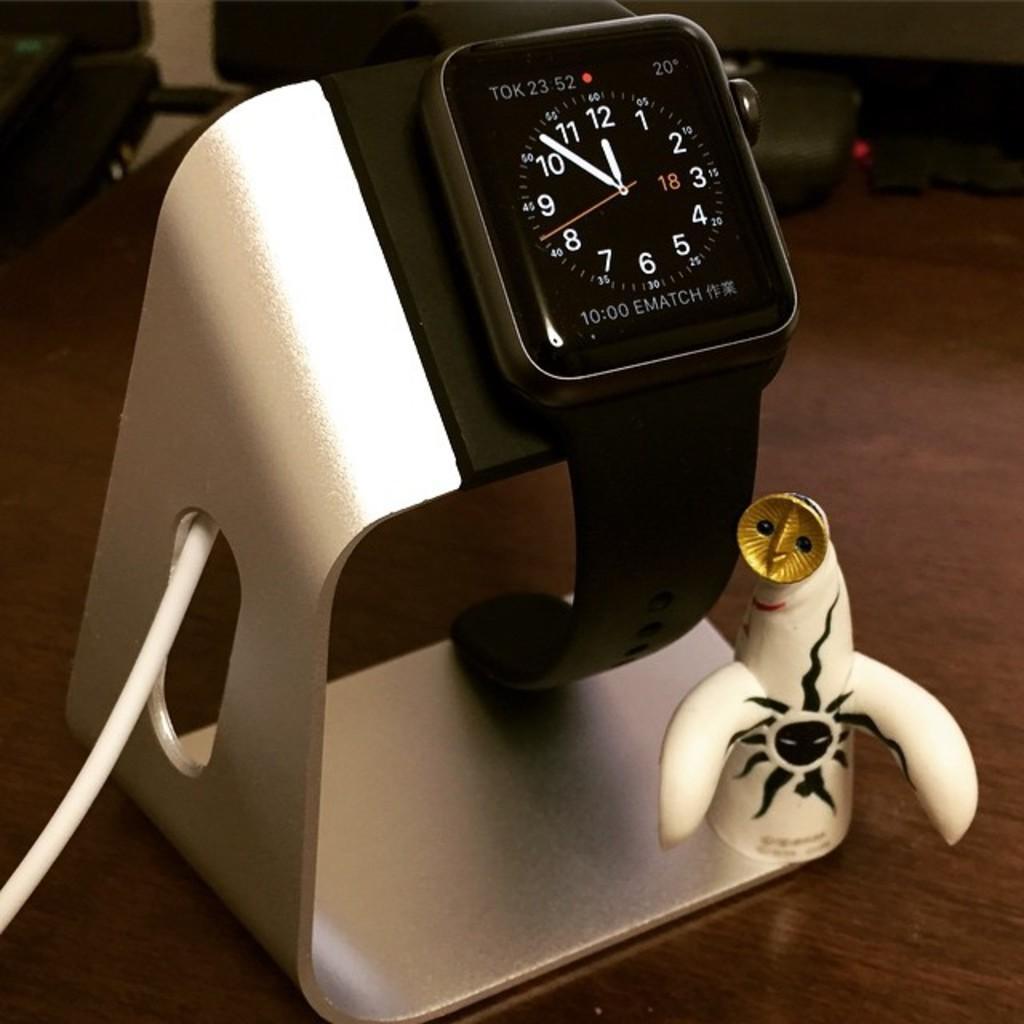Describe this image in one or two sentences. In this image I can see a black color watch visible on stand and the stand is kept on table and I can see a cable card attached to the stand on the left side and at the top I can see chairs visible in front of the table. 